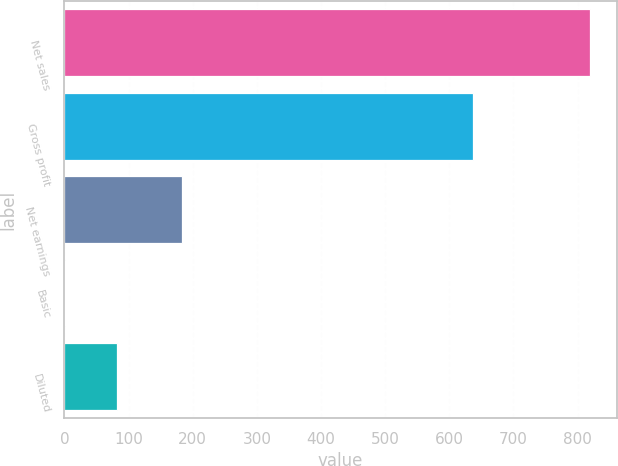Convert chart to OTSL. <chart><loc_0><loc_0><loc_500><loc_500><bar_chart><fcel>Net sales<fcel>Gross profit<fcel>Net earnings<fcel>Basic<fcel>Diluted<nl><fcel>819.8<fcel>636.6<fcel>183.3<fcel>0.76<fcel>82.66<nl></chart> 